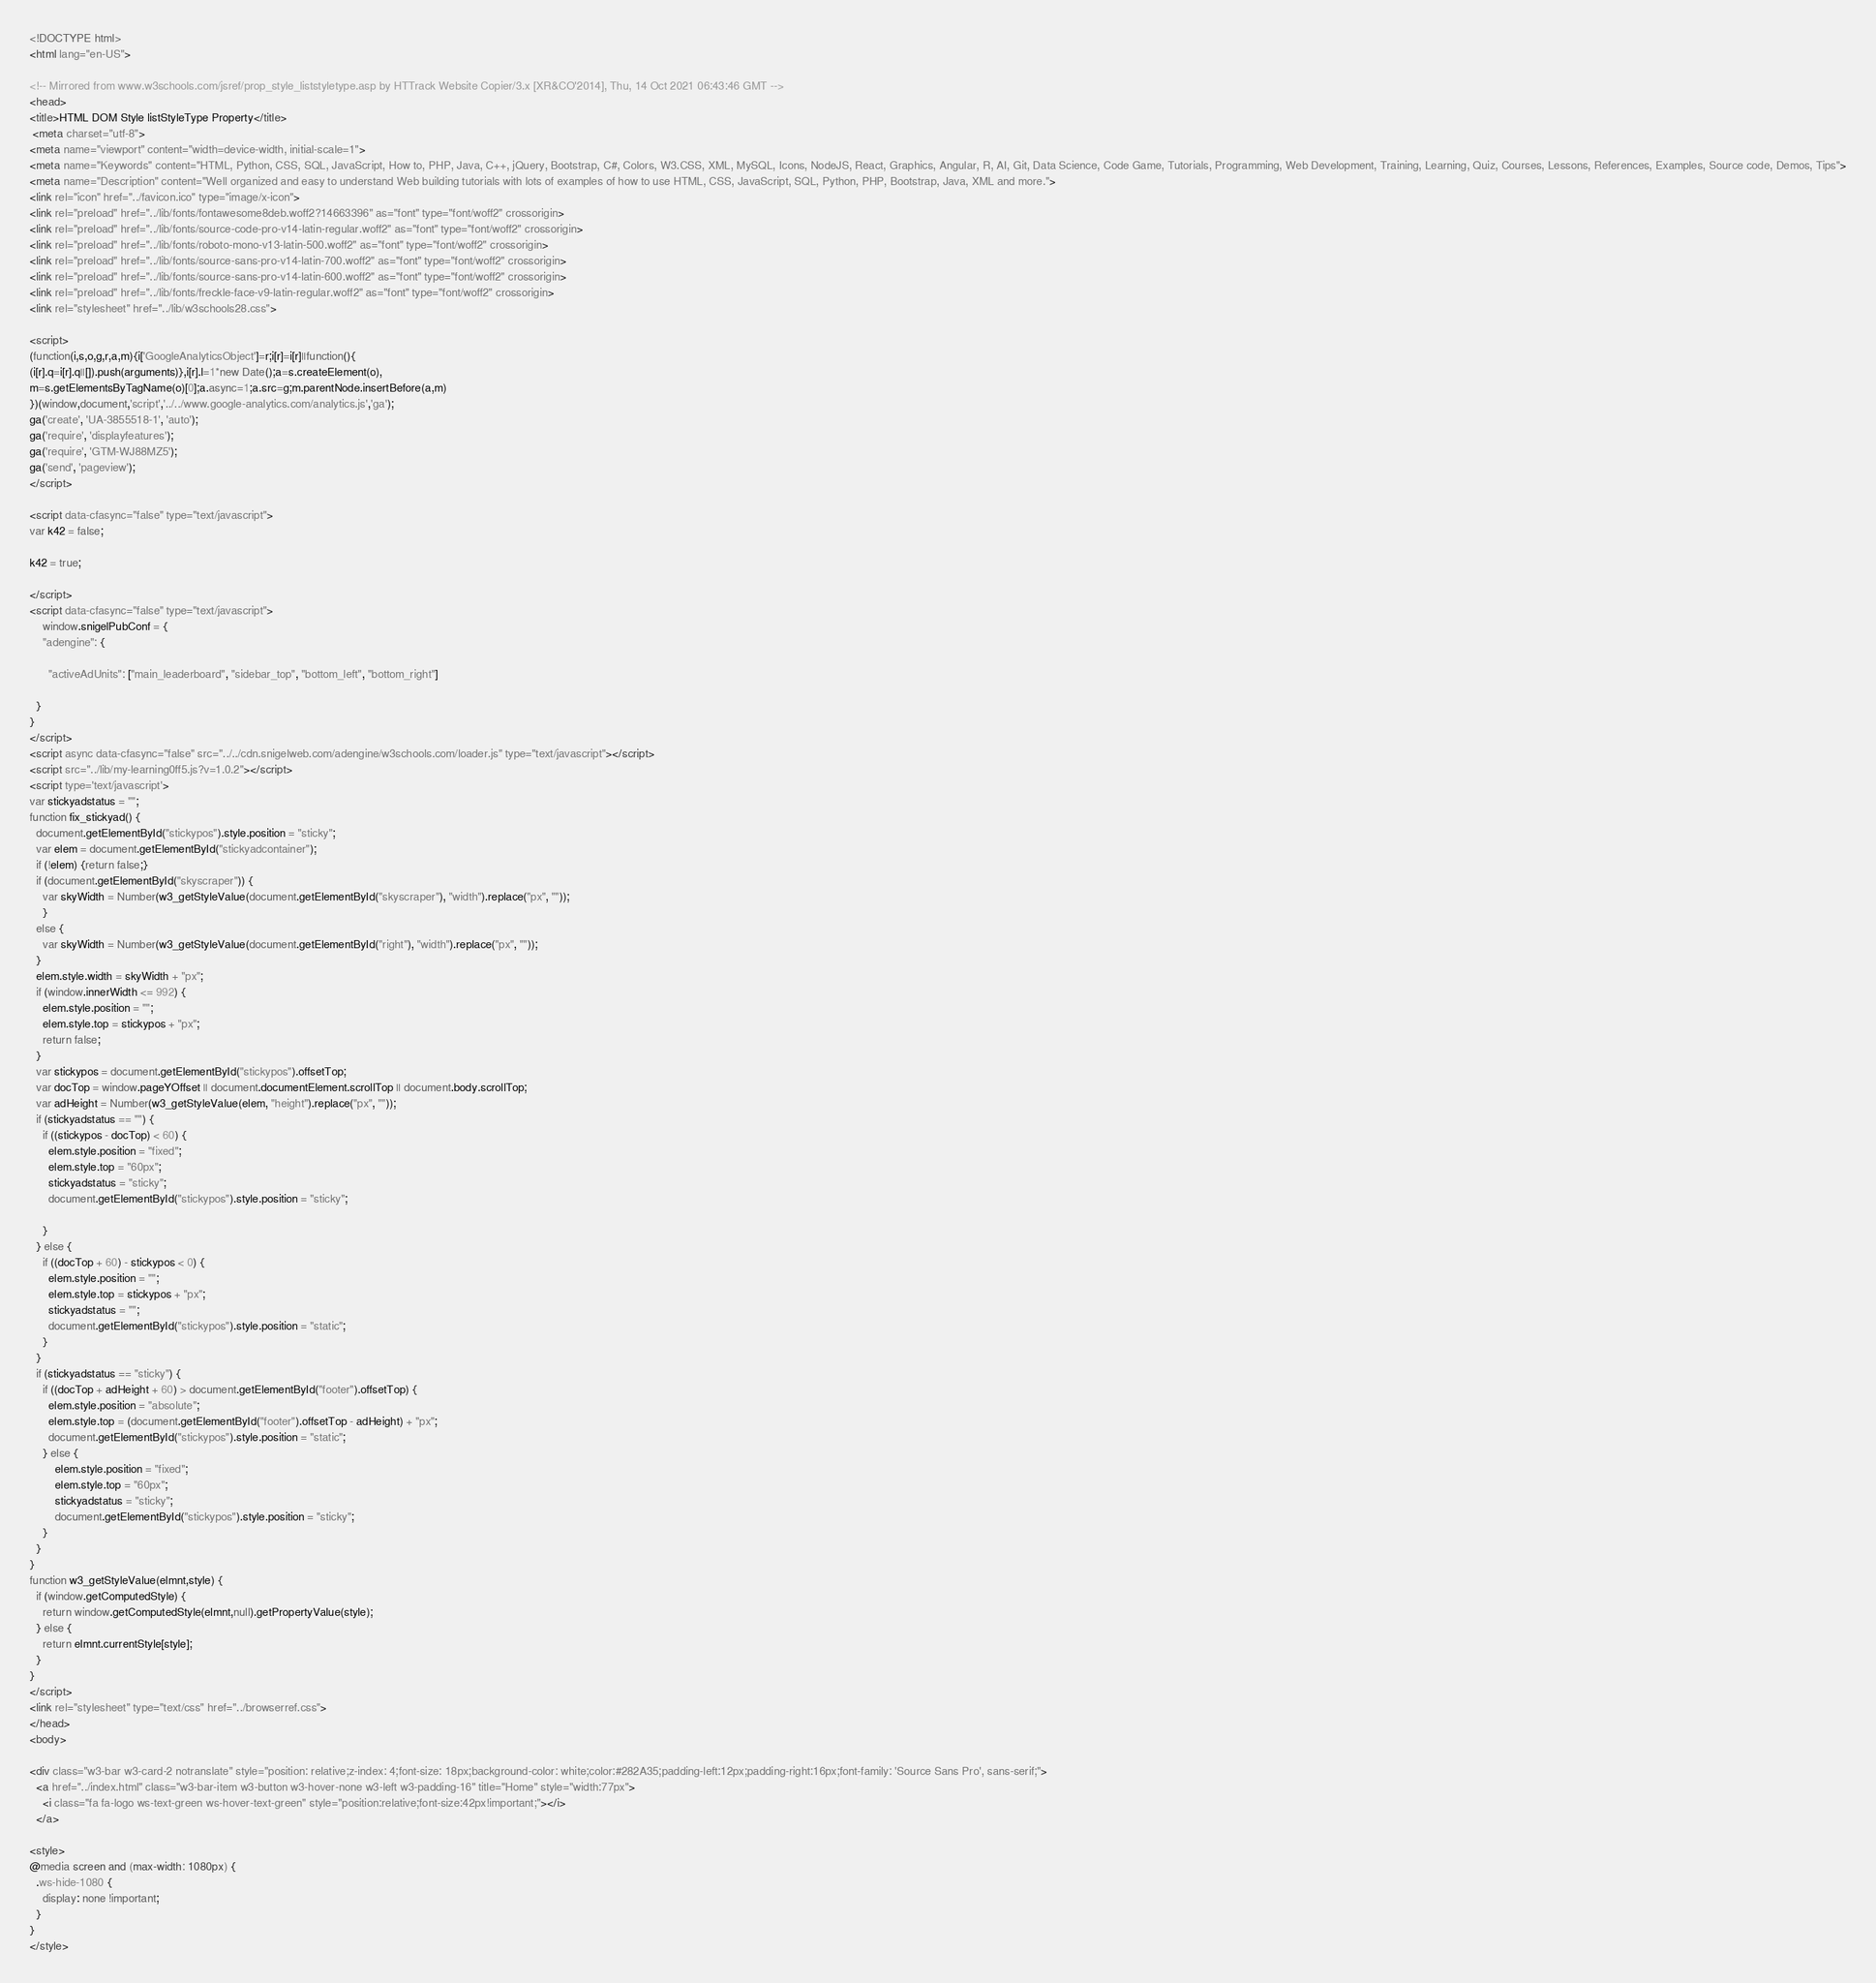<code> <loc_0><loc_0><loc_500><loc_500><_HTML_>
<!DOCTYPE html>
<html lang="en-US">

<!-- Mirrored from www.w3schools.com/jsref/prop_style_liststyletype.asp by HTTrack Website Copier/3.x [XR&CO'2014], Thu, 14 Oct 2021 06:43:46 GMT -->
<head>
<title>HTML DOM Style listStyleType Property</title>
 <meta charset="utf-8">
<meta name="viewport" content="width=device-width, initial-scale=1">
<meta name="Keywords" content="HTML, Python, CSS, SQL, JavaScript, How to, PHP, Java, C++, jQuery, Bootstrap, C#, Colors, W3.CSS, XML, MySQL, Icons, NodeJS, React, Graphics, Angular, R, AI, Git, Data Science, Code Game, Tutorials, Programming, Web Development, Training, Learning, Quiz, Courses, Lessons, References, Examples, Source code, Demos, Tips">
<meta name="Description" content="Well organized and easy to understand Web building tutorials with lots of examples of how to use HTML, CSS, JavaScript, SQL, Python, PHP, Bootstrap, Java, XML and more.">
<link rel="icon" href="../favicon.ico" type="image/x-icon">
<link rel="preload" href="../lib/fonts/fontawesome8deb.woff2?14663396" as="font" type="font/woff2" crossorigin> 
<link rel="preload" href="../lib/fonts/source-code-pro-v14-latin-regular.woff2" as="font" type="font/woff2" crossorigin> 
<link rel="preload" href="../lib/fonts/roboto-mono-v13-latin-500.woff2" as="font" type="font/woff2" crossorigin> 
<link rel="preload" href="../lib/fonts/source-sans-pro-v14-latin-700.woff2" as="font" type="font/woff2" crossorigin> 
<link rel="preload" href="../lib/fonts/source-sans-pro-v14-latin-600.woff2" as="font" type="font/woff2" crossorigin> 
<link rel="preload" href="../lib/fonts/freckle-face-v9-latin-regular.woff2" as="font" type="font/woff2" crossorigin> 
<link rel="stylesheet" href="../lib/w3schools28.css">

<script>
(function(i,s,o,g,r,a,m){i['GoogleAnalyticsObject']=r;i[r]=i[r]||function(){
(i[r].q=i[r].q||[]).push(arguments)},i[r].l=1*new Date();a=s.createElement(o),
m=s.getElementsByTagName(o)[0];a.async=1;a.src=g;m.parentNode.insertBefore(a,m)
})(window,document,'script','../../www.google-analytics.com/analytics.js','ga');
ga('create', 'UA-3855518-1', 'auto');
ga('require', 'displayfeatures');
ga('require', 'GTM-WJ88MZ5');
ga('send', 'pageview');
</script>

<script data-cfasync="false" type="text/javascript">
var k42 = false;

k42 = true;

</script>
<script data-cfasync="false" type="text/javascript">
    window.snigelPubConf = {
    "adengine": {

      "activeAdUnits": ["main_leaderboard", "sidebar_top", "bottom_left", "bottom_right"]

  }
}
</script>
<script async data-cfasync="false" src="../../cdn.snigelweb.com/adengine/w3schools.com/loader.js" type="text/javascript"></script>
<script src="../lib/my-learning0ff5.js?v=1.0.2"></script>
<script type='text/javascript'>
var stickyadstatus = "";
function fix_stickyad() {
  document.getElementById("stickypos").style.position = "sticky";
  var elem = document.getElementById("stickyadcontainer");
  if (!elem) {return false;}
  if (document.getElementById("skyscraper")) {
    var skyWidth = Number(w3_getStyleValue(document.getElementById("skyscraper"), "width").replace("px", ""));  
    }
  else {
    var skyWidth = Number(w3_getStyleValue(document.getElementById("right"), "width").replace("px", ""));  
  }
  elem.style.width = skyWidth + "px";
  if (window.innerWidth <= 992) {
    elem.style.position = "";
    elem.style.top = stickypos + "px";
    return false;
  }
  var stickypos = document.getElementById("stickypos").offsetTop;
  var docTop = window.pageYOffset || document.documentElement.scrollTop || document.body.scrollTop;
  var adHeight = Number(w3_getStyleValue(elem, "height").replace("px", ""));
  if (stickyadstatus == "") {
    if ((stickypos - docTop) < 60) {
      elem.style.position = "fixed";
      elem.style.top = "60px";
      stickyadstatus = "sticky";
      document.getElementById("stickypos").style.position = "sticky";

    }
  } else {
    if ((docTop + 60) - stickypos < 0) {  
      elem.style.position = "";
      elem.style.top = stickypos + "px";
      stickyadstatus = "";
      document.getElementById("stickypos").style.position = "static";
    }
  }
  if (stickyadstatus == "sticky") {
    if ((docTop + adHeight + 60) > document.getElementById("footer").offsetTop) {
      elem.style.position = "absolute";
      elem.style.top = (document.getElementById("footer").offsetTop - adHeight) + "px";
      document.getElementById("stickypos").style.position = "static";
    } else {
        elem.style.position = "fixed";
        elem.style.top = "60px";
        stickyadstatus = "sticky";
        document.getElementById("stickypos").style.position = "sticky";
    }
  }
}
function w3_getStyleValue(elmnt,style) {
  if (window.getComputedStyle) {
    return window.getComputedStyle(elmnt,null).getPropertyValue(style);
  } else {
    return elmnt.currentStyle[style];
  }
}
</script>
<link rel="stylesheet" type="text/css" href="../browserref.css">
</head>
<body>

<div class="w3-bar w3-card-2 notranslate" style="position: relative;z-index: 4;font-size: 18px;background-color: white;color:#282A35;padding-left:12px;padding-right:16px;font-family: 'Source Sans Pro', sans-serif;">
  <a href="../index.html" class="w3-bar-item w3-button w3-hover-none w3-left w3-padding-16" title="Home" style="width:77px">
    <i class="fa fa-logo ws-text-green ws-hover-text-green" style="position:relative;font-size:42px!important;"></i>
  </a>

<style>
@media screen and (max-width: 1080px) {
  .ws-hide-1080 {
    display: none !important;
  }
}
</style>
</code> 